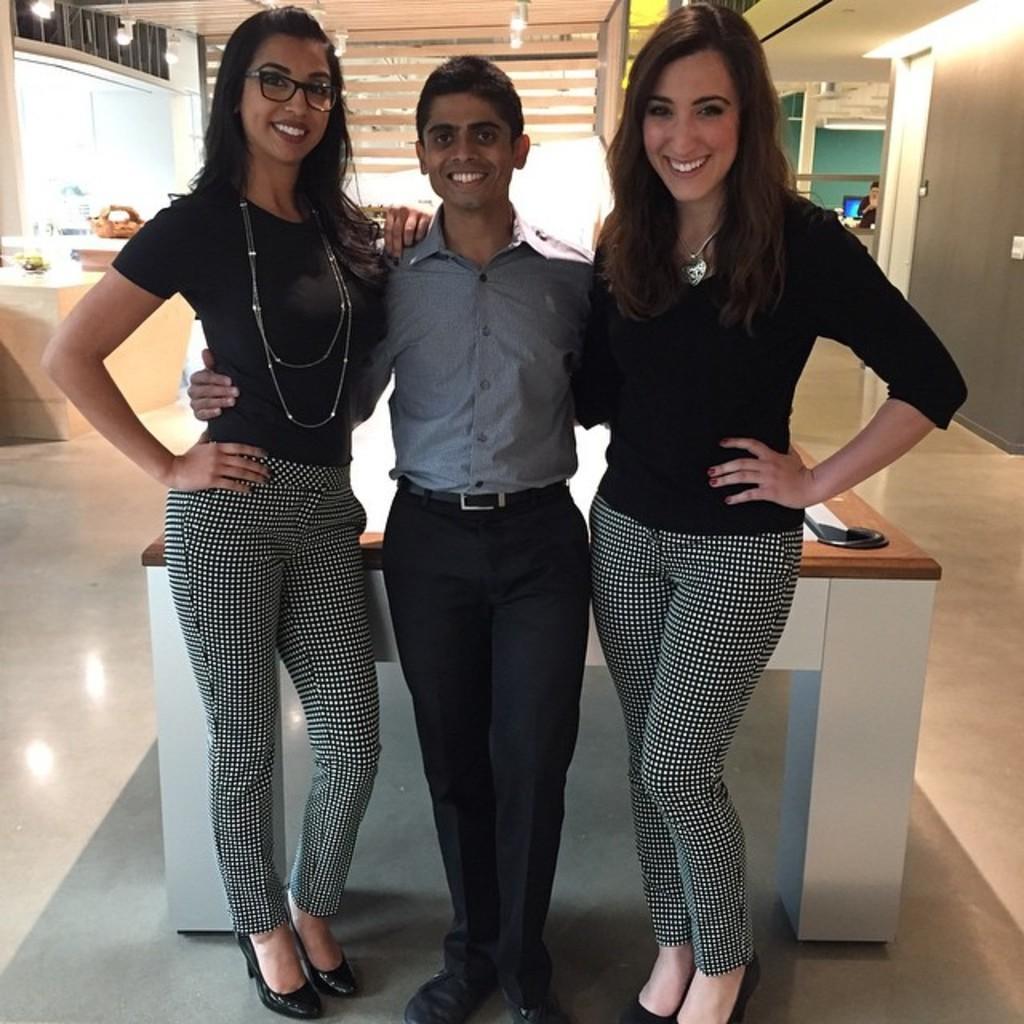Could you give a brief overview of what you see in this image? In this there is a man who is wearing shirt and shoe. Beside him there are two women who were wearing black top and shoe. Three of them standing near to the table. On the right background we can see a man who is standing near to the system. On the left background we can see the flowers and other objects on the desk which is near to the window. On the top we can see the lights. 